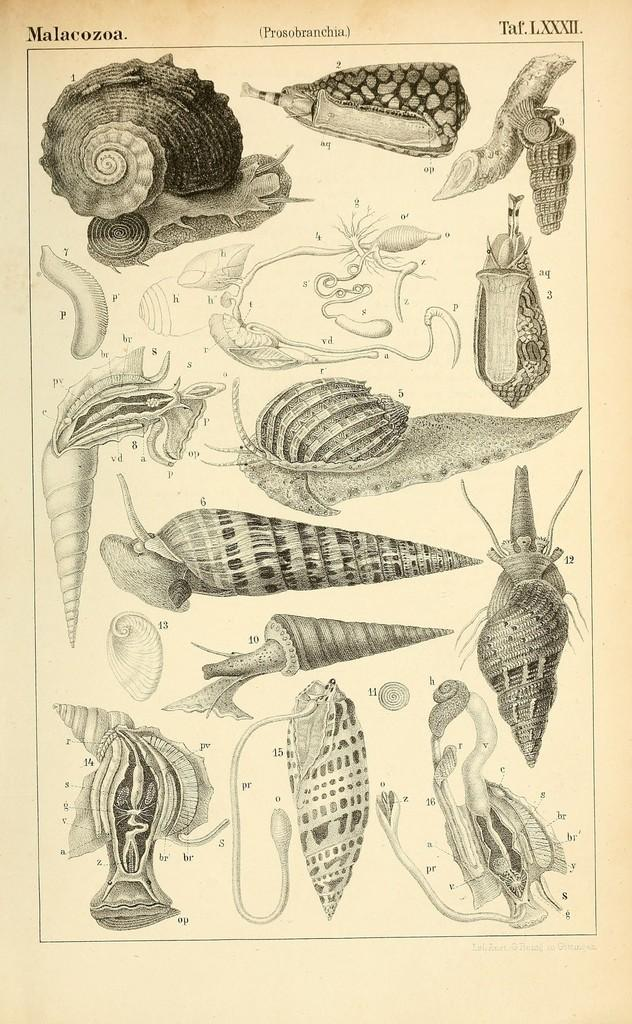What is the main subject of the image? The main subject of the image is an art display. What type of items are featured in the art display? The art display features different kinds of sea shells. How can the viewer identify the types of sea shells? The sea shells have labeling. What can be seen on the top of the image? There are watermarks on the top of the image. Can you tell me how many gloves are being exchanged in the image? There are no gloves or exchange of items depicted in the image; it features an art display with sea shells. 